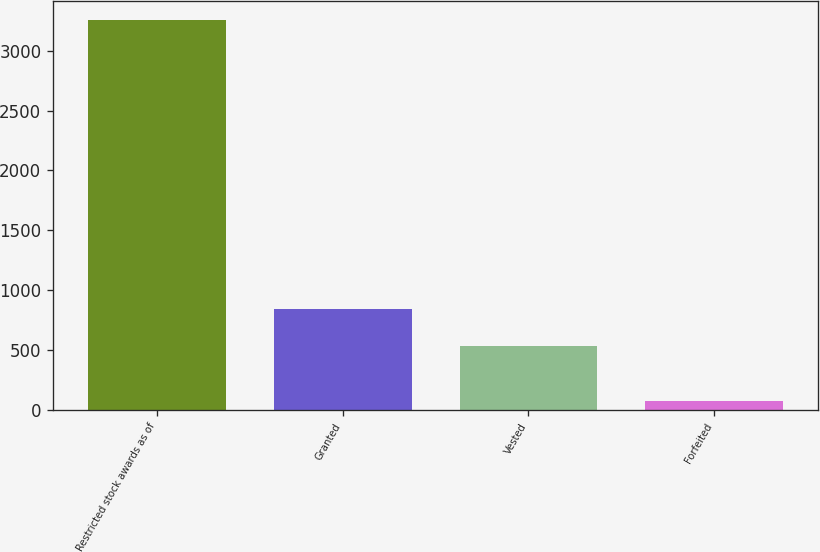Convert chart. <chart><loc_0><loc_0><loc_500><loc_500><bar_chart><fcel>Restricted stock awards as of<fcel>Granted<fcel>Vested<fcel>Forfeited<nl><fcel>3253.2<fcel>842.2<fcel>538<fcel>74<nl></chart> 